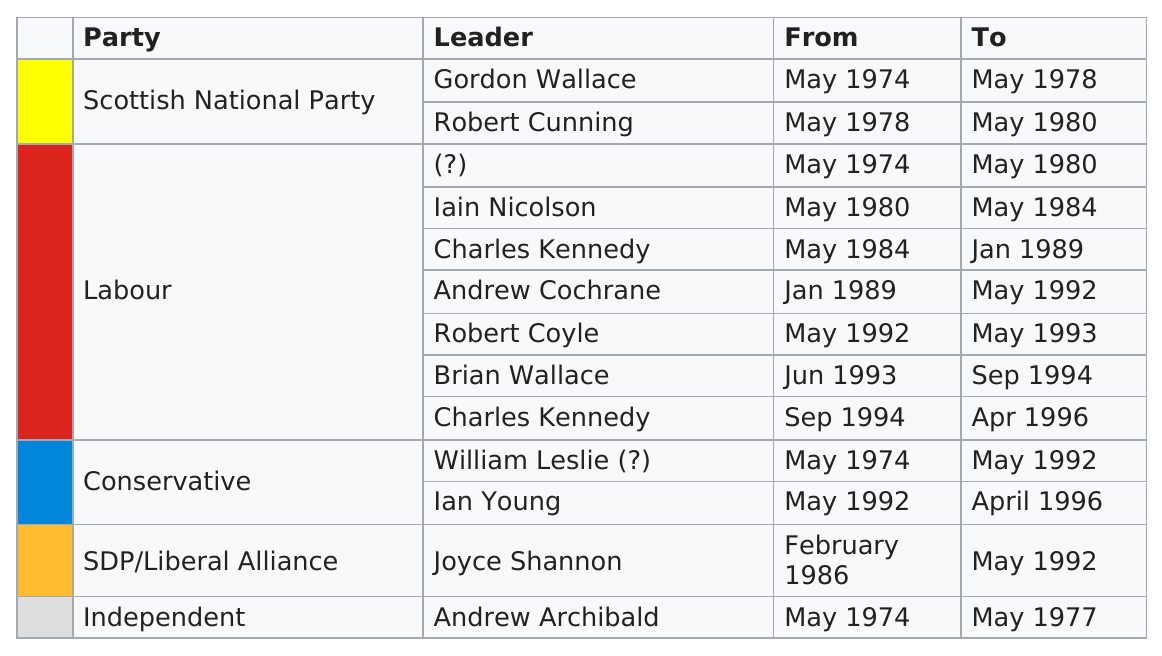Mention a couple of crucial points in this snapshot. William Leslie served more years than Joyce Shannon. The Independent party had only one leader and a three-year office term. It is unclear whether Charles Kennedy or Joyce Shannon spent more time in office. Joyce Shannon held the record for the longest-serving female MP in the UK. There was at least one party that had the same leader in office for two consecutive terms. Since January 1989, the Labour Party has had four group leaders. 